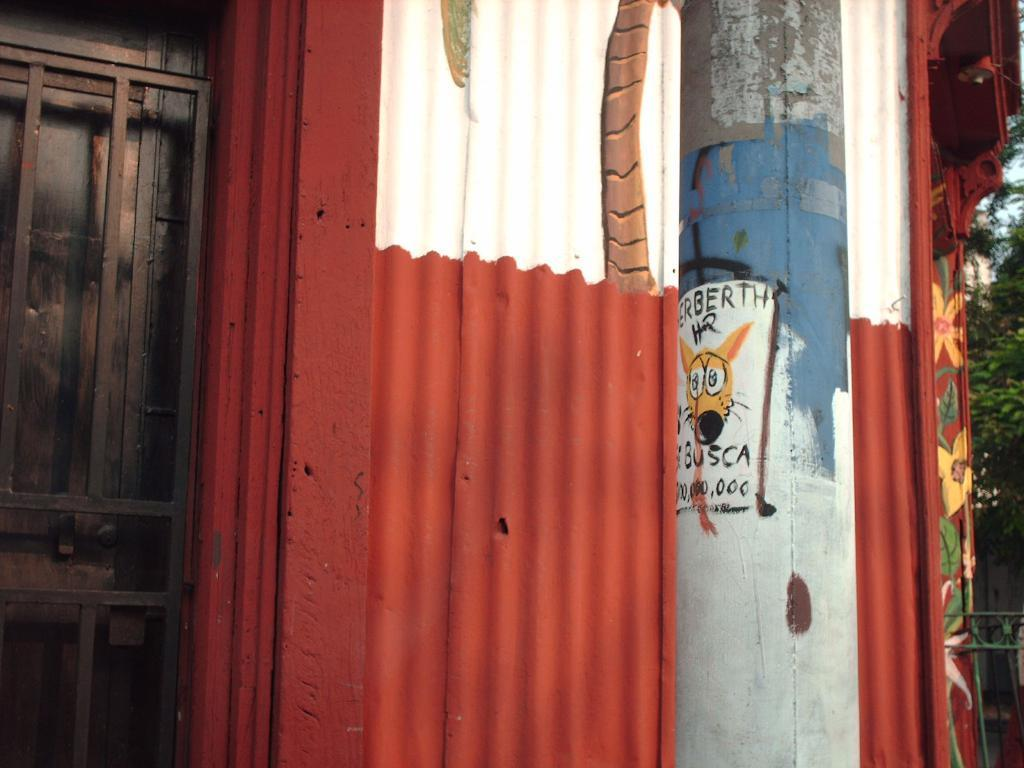What is the tall, vertical object in the image? There is a pole in the image. What is the flat, solid structure in the image? A: There is a wall in the image. What is the opening in the wall that can be used for entering or exiting? There is a door in the image. What type of plant is visible in the image? There is a tree in the image. What part of the natural environment is visible in the image? The sky is visible in the image. What is the name of the dock in the image? There is no dock present in the image. How does the wall show respect in the image? The wall does not show respect; it is a physical structure. 